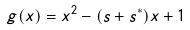<formula> <loc_0><loc_0><loc_500><loc_500>{ } g ( x ) = x ^ { 2 } - ( s + s ^ { * } ) x + 1</formula> 